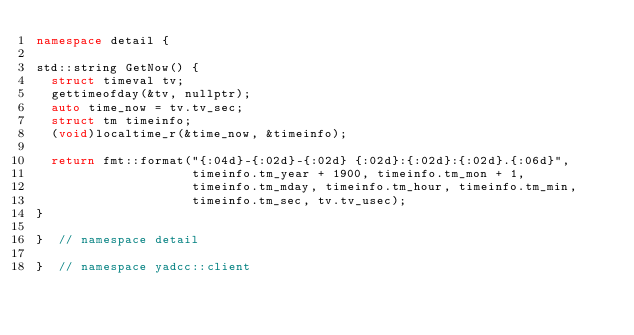<code> <loc_0><loc_0><loc_500><loc_500><_C++_>namespace detail {

std::string GetNow() {
  struct timeval tv;
  gettimeofday(&tv, nullptr);
  auto time_now = tv.tv_sec;
  struct tm timeinfo;
  (void)localtime_r(&time_now, &timeinfo);

  return fmt::format("{:04d}-{:02d}-{:02d} {:02d}:{:02d}:{:02d}.{:06d}",
                     timeinfo.tm_year + 1900, timeinfo.tm_mon + 1,
                     timeinfo.tm_mday, timeinfo.tm_hour, timeinfo.tm_min,
                     timeinfo.tm_sec, tv.tv_usec);
}

}  // namespace detail

}  // namespace yadcc::client
</code> 